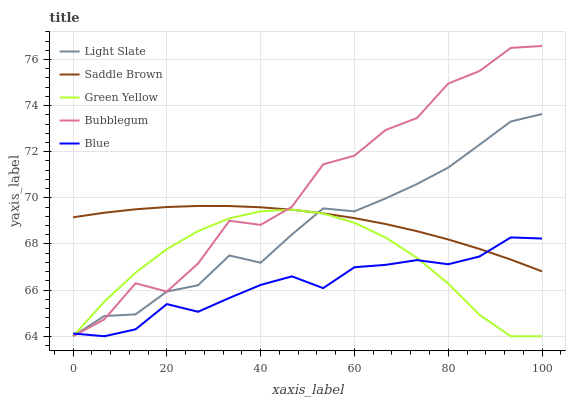Does Green Yellow have the minimum area under the curve?
Answer yes or no. No. Does Green Yellow have the maximum area under the curve?
Answer yes or no. No. Is Blue the smoothest?
Answer yes or no. No. Is Blue the roughest?
Answer yes or no. No. Does Saddle Brown have the lowest value?
Answer yes or no. No. Does Green Yellow have the highest value?
Answer yes or no. No. 